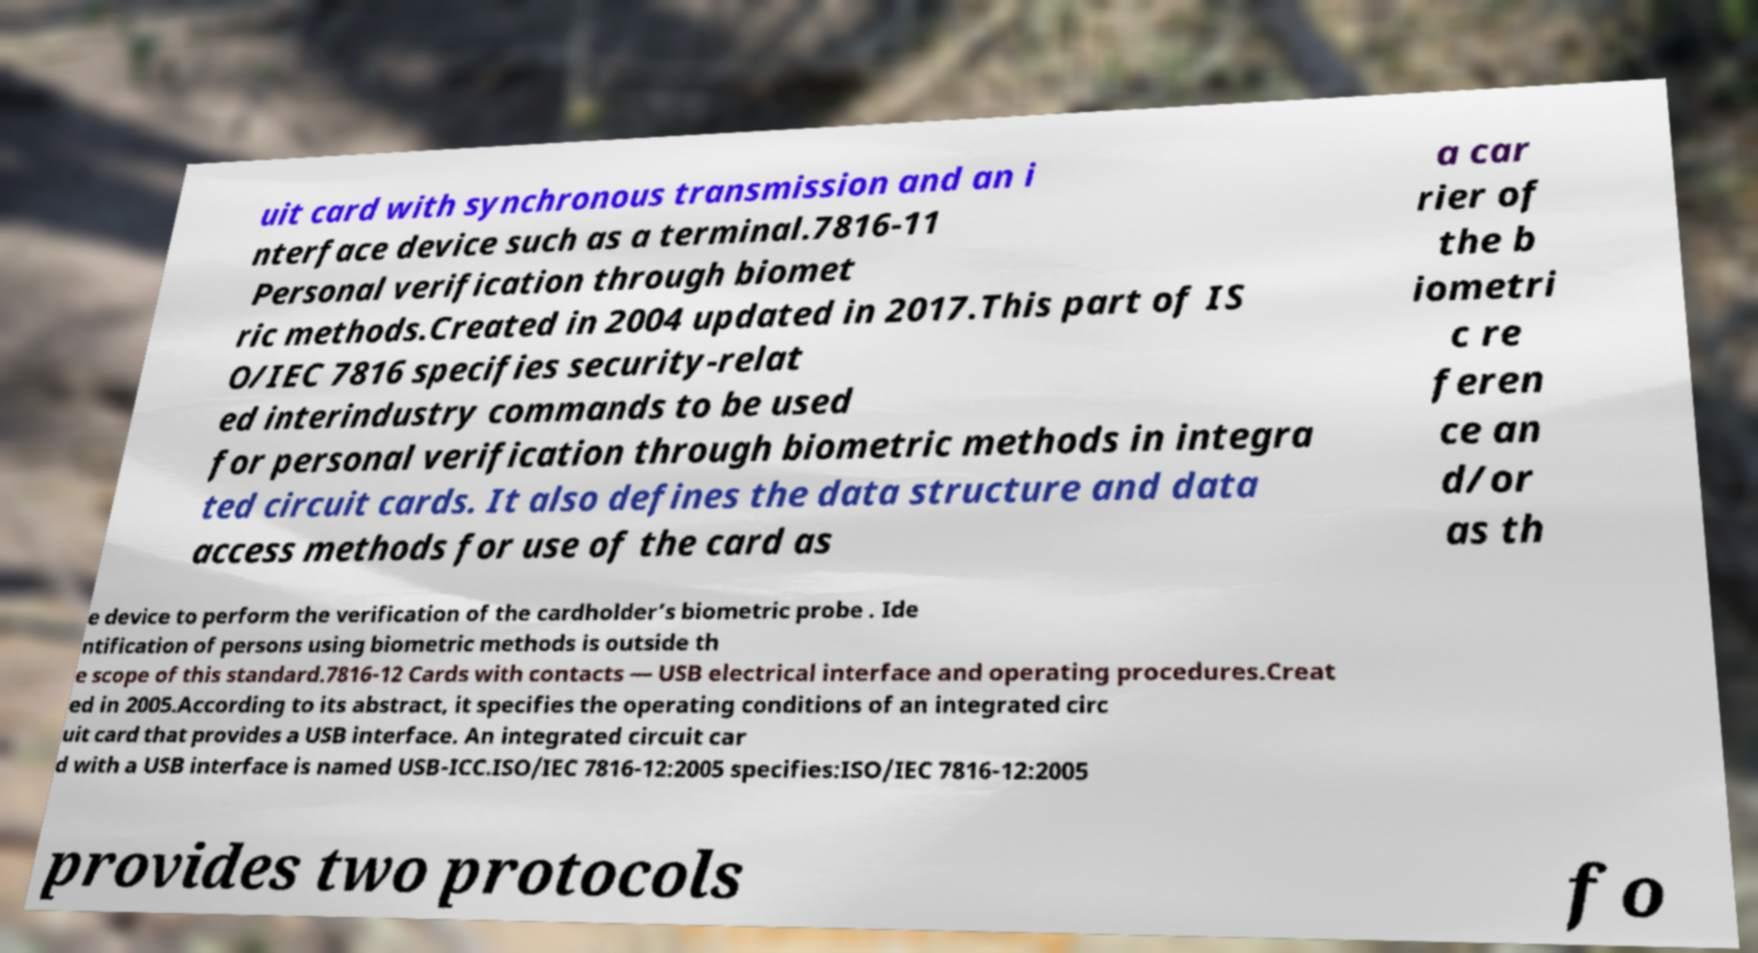There's text embedded in this image that I need extracted. Can you transcribe it verbatim? uit card with synchronous transmission and an i nterface device such as a terminal.7816-11 Personal verification through biomet ric methods.Created in 2004 updated in 2017.This part of IS O/IEC 7816 specifies security-relat ed interindustry commands to be used for personal verification through biometric methods in integra ted circuit cards. It also defines the data structure and data access methods for use of the card as a car rier of the b iometri c re feren ce an d/or as th e device to perform the verification of the cardholder’s biometric probe . Ide ntification of persons using biometric methods is outside th e scope of this standard.7816-12 Cards with contacts — USB electrical interface and operating procedures.Creat ed in 2005.According to its abstract, it specifies the operating conditions of an integrated circ uit card that provides a USB interface. An integrated circuit car d with a USB interface is named USB-ICC.ISO/IEC 7816-12:2005 specifies:ISO/IEC 7816-12:2005 provides two protocols fo 